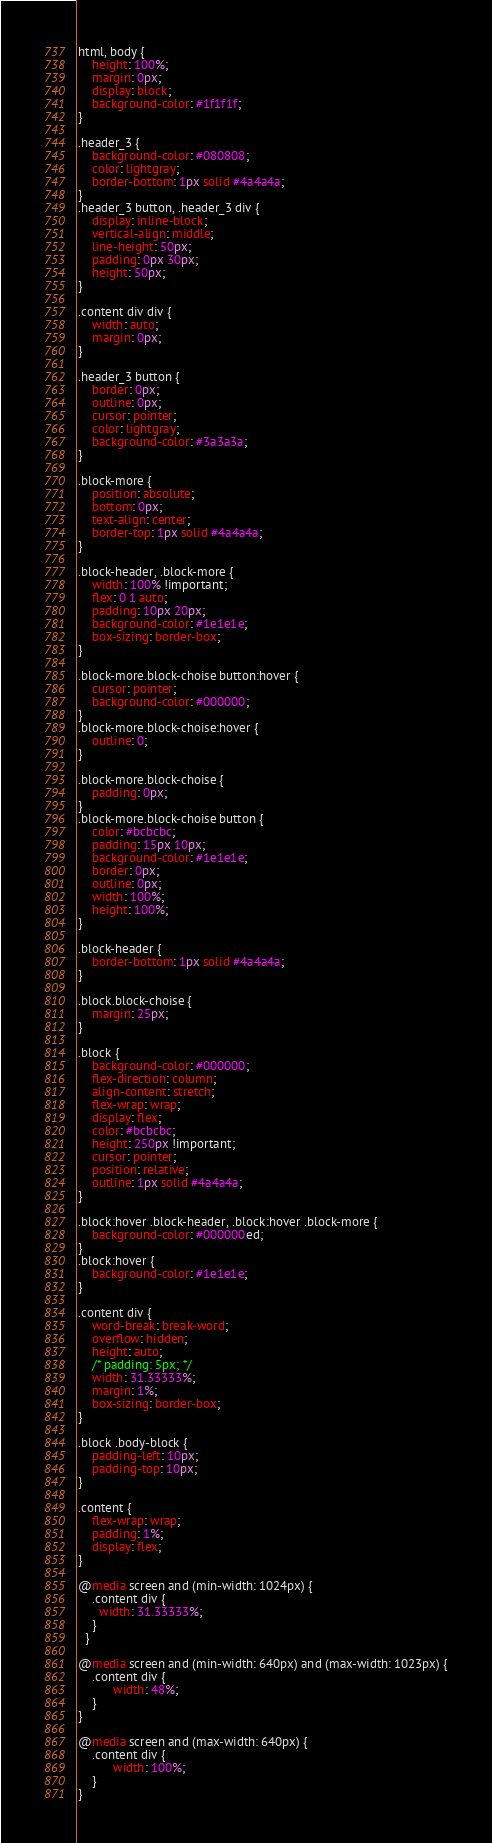<code> <loc_0><loc_0><loc_500><loc_500><_CSS_>html, body {
    height: 100%;
    margin: 0px;
    display: block;
    background-color: #1f1f1f;
}

.header_3 {
    background-color: #080808;
    color: lightgray;
    border-bottom: 1px solid #4a4a4a;   
}
.header_3 button, .header_3 div {
    display: inline-block;
    vertical-align: middle;
    line-height: 50px;
    padding: 0px 30px;
    height: 50px;
}

.content div div {
    width: auto;
    margin: 0px;
}

.header_3 button {
    border: 0px;
    outline: 0px;
    cursor: pointer;
    color: lightgray;
    background-color: #3a3a3a;
}

.block-more {
    position: absolute;
    bottom: 0px;
    text-align: center;
    border-top: 1px solid #4a4a4a;
}

.block-header, .block-more {
    width: 100% !important;
    flex: 0 1 auto;
    padding: 10px 20px;
    background-color: #1e1e1e;
    box-sizing: border-box;
}

.block-more.block-choise button:hover {
    cursor: pointer;
    background-color: #000000;
}
.block-more.block-choise:hover {
    outline: 0;
}

.block-more.block-choise {
    padding: 0px;
}
.block-more.block-choise button {
    color: #bcbcbc;
    padding: 15px 10px;
    background-color: #1e1e1e;
    border: 0px;
    outline: 0px;
    width: 100%;
    height: 100%;
}

.block-header {
    border-bottom: 1px solid #4a4a4a;
}

.block.block-choise {
    margin: 25px;
}

.block {
    background-color: #000000;
    flex-direction: column;
    align-content: stretch;
    flex-wrap: wrap;
    display: flex;
    color: #bcbcbc;
    height: 250px !important;
    cursor: pointer;
    position: relative;
    outline: 1px solid #4a4a4a;
}

.block:hover .block-header, .block:hover .block-more {
    background-color: #000000ed;
}
.block:hover {
    background-color: #1e1e1e;
}

.content div {
    word-break: break-word;
    overflow: hidden;
    height: auto;
    /* padding: 5px; */
    width: 31.33333%;
    margin: 1%;
    box-sizing: border-box;
}

.block .body-block {
    padding-left: 10px;
    padding-top: 10px;
}

.content {
    flex-wrap: wrap;
    padding: 1%;
    display: flex;
}

@media screen and (min-width: 1024px) {
    .content div {
      width: 31.33333%;
    }
  }

@media screen and (min-width: 640px) and (max-width: 1023px) {
    .content div {
          width: 48%;
    }
}

@media screen and (max-width: 640px) {
    .content div {
          width: 100%;
    }
}</code> 